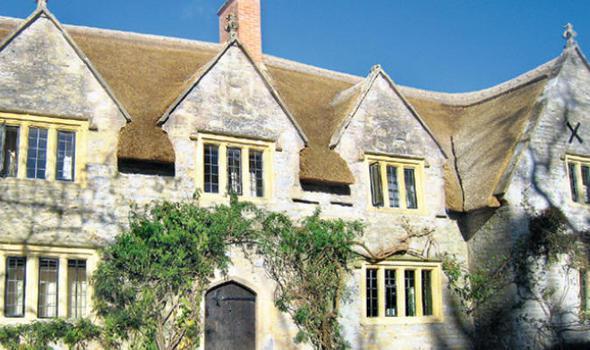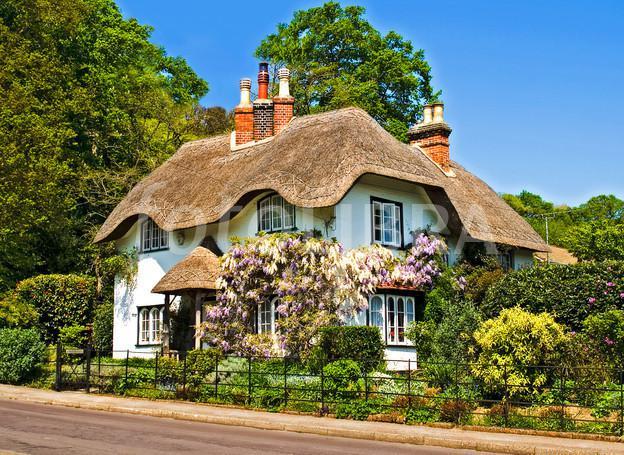The first image is the image on the left, the second image is the image on the right. Given the left and right images, does the statement "At least two humans are visible." hold true? Answer yes or no. No. 